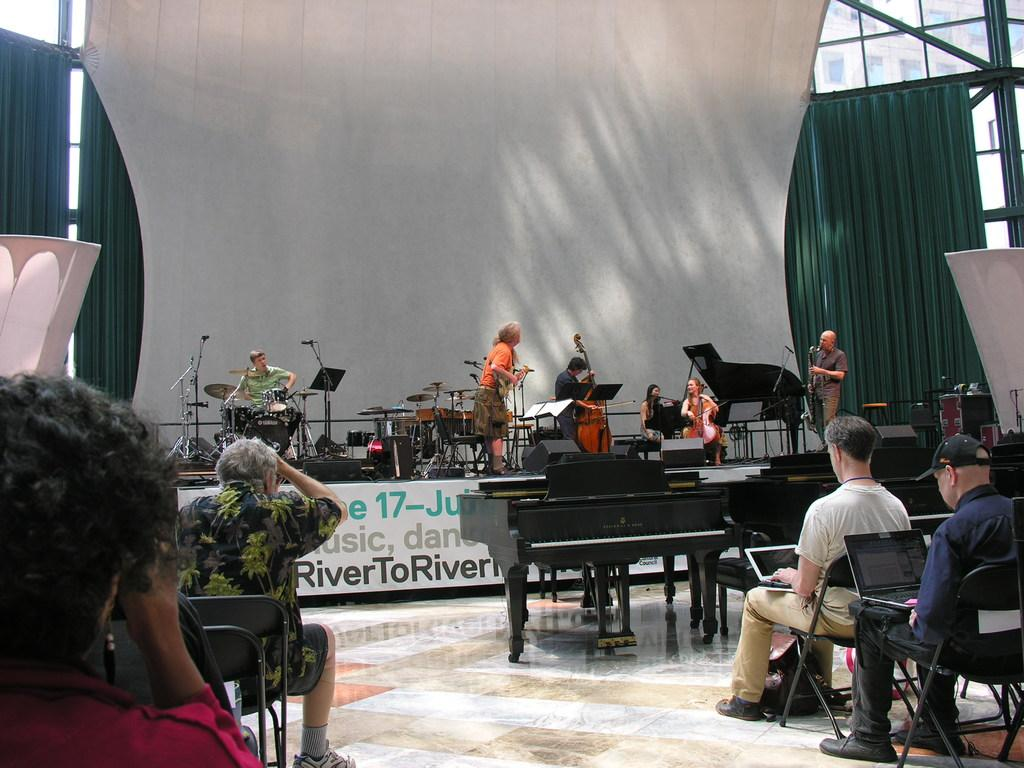What are the people in the image doing? The people in the image are sitting on chairs and playing musical instruments on a stage. What objects can be seen on the table in the image? There are laptops on a table in the image. What type of linen is draped over the chairs in the image? There is no linen draped over the chairs in the image; the chairs are empty. 